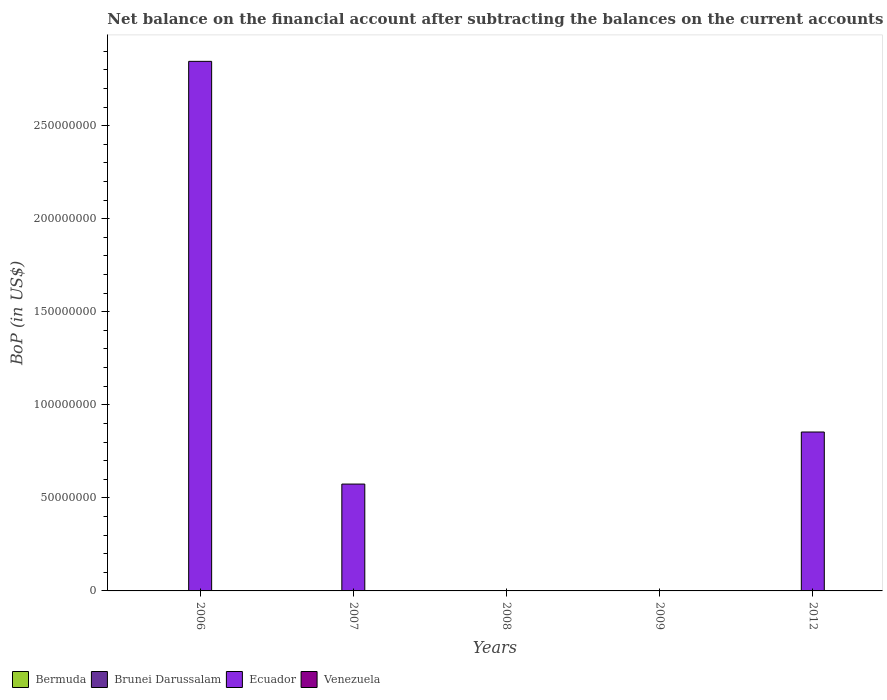Are the number of bars per tick equal to the number of legend labels?
Make the answer very short. No. Are the number of bars on each tick of the X-axis equal?
Keep it short and to the point. No. How many bars are there on the 3rd tick from the left?
Make the answer very short. 0. How many bars are there on the 5th tick from the right?
Ensure brevity in your answer.  1. What is the label of the 5th group of bars from the left?
Provide a succinct answer. 2012. In how many cases, is the number of bars for a given year not equal to the number of legend labels?
Give a very brief answer. 5. What is the Balance of Payments in Brunei Darussalam in 2009?
Give a very brief answer. 0. Across all years, what is the maximum Balance of Payments in Ecuador?
Keep it short and to the point. 2.85e+08. In which year was the Balance of Payments in Ecuador maximum?
Make the answer very short. 2006. What is the difference between the Balance of Payments in Ecuador in 2007 and that in 2012?
Offer a very short reply. -2.80e+07. What is the average Balance of Payments in Brunei Darussalam per year?
Offer a very short reply. 0. What is the ratio of the Balance of Payments in Ecuador in 2007 to that in 2012?
Give a very brief answer. 0.67. Is the Balance of Payments in Ecuador in 2006 less than that in 2007?
Your answer should be very brief. No. What is the difference between the highest and the lowest Balance of Payments in Ecuador?
Give a very brief answer. 2.85e+08. What is the difference between two consecutive major ticks on the Y-axis?
Ensure brevity in your answer.  5.00e+07. Where does the legend appear in the graph?
Offer a terse response. Bottom left. What is the title of the graph?
Offer a very short reply. Net balance on the financial account after subtracting the balances on the current accounts. What is the label or title of the Y-axis?
Give a very brief answer. BoP (in US$). What is the BoP (in US$) in Bermuda in 2006?
Provide a short and direct response. 0. What is the BoP (in US$) of Ecuador in 2006?
Give a very brief answer. 2.85e+08. What is the BoP (in US$) in Venezuela in 2006?
Your answer should be very brief. 0. What is the BoP (in US$) in Bermuda in 2007?
Give a very brief answer. 0. What is the BoP (in US$) in Brunei Darussalam in 2007?
Offer a terse response. 0. What is the BoP (in US$) of Ecuador in 2007?
Provide a short and direct response. 5.74e+07. What is the BoP (in US$) of Venezuela in 2007?
Give a very brief answer. 0. What is the BoP (in US$) of Bermuda in 2008?
Make the answer very short. 0. What is the BoP (in US$) of Ecuador in 2008?
Provide a succinct answer. 0. What is the BoP (in US$) of Venezuela in 2008?
Your response must be concise. 0. What is the BoP (in US$) in Bermuda in 2009?
Keep it short and to the point. 0. What is the BoP (in US$) in Ecuador in 2009?
Provide a short and direct response. 0. What is the BoP (in US$) in Ecuador in 2012?
Keep it short and to the point. 8.54e+07. Across all years, what is the maximum BoP (in US$) in Ecuador?
Your answer should be compact. 2.85e+08. Across all years, what is the minimum BoP (in US$) in Ecuador?
Offer a very short reply. 0. What is the total BoP (in US$) in Ecuador in the graph?
Your response must be concise. 4.27e+08. What is the difference between the BoP (in US$) in Ecuador in 2006 and that in 2007?
Make the answer very short. 2.27e+08. What is the difference between the BoP (in US$) in Ecuador in 2006 and that in 2012?
Provide a succinct answer. 1.99e+08. What is the difference between the BoP (in US$) in Ecuador in 2007 and that in 2012?
Your answer should be compact. -2.80e+07. What is the average BoP (in US$) in Ecuador per year?
Offer a very short reply. 8.55e+07. What is the ratio of the BoP (in US$) in Ecuador in 2006 to that in 2007?
Keep it short and to the point. 4.96. What is the ratio of the BoP (in US$) of Ecuador in 2006 to that in 2012?
Your answer should be compact. 3.33. What is the ratio of the BoP (in US$) of Ecuador in 2007 to that in 2012?
Your answer should be very brief. 0.67. What is the difference between the highest and the second highest BoP (in US$) in Ecuador?
Give a very brief answer. 1.99e+08. What is the difference between the highest and the lowest BoP (in US$) in Ecuador?
Offer a terse response. 2.85e+08. 